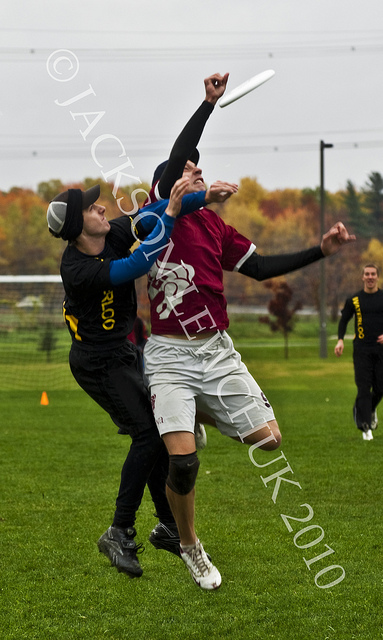What might stop you from using this image in a commercial capacity? The most prominent issue preventing the commercial use of this image is the visible watermark '©JACKSON CHURCH 2010' across the center. Watermarks are used to protect copyright and signal ownership, and using such watermarked images without permission could lead to legal challenges. 